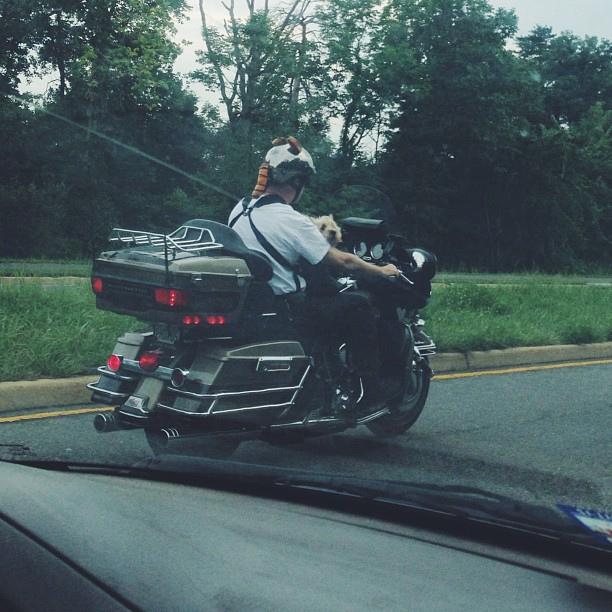How many wheels are in this picture?
Keep it brief. 2. Is the man wearing gloves?
Answer briefly. No. Is the person looking at the road?
Give a very brief answer. Yes. Is this the park?
Write a very short answer. No. 